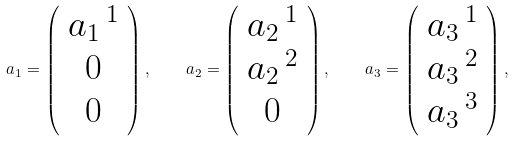Convert formula to latex. <formula><loc_0><loc_0><loc_500><loc_500>a _ { 1 } = \left ( \begin{array} { c } a _ { 1 } \, ^ { 1 } \\ 0 \\ 0 \end{array} \right ) , \quad a _ { 2 } = \left ( \begin{array} { c } a _ { 2 } \, ^ { 1 } \\ a _ { 2 } \, ^ { 2 } \\ 0 \end{array} \right ) , \quad a _ { 3 } = \left ( \begin{array} { c } a _ { 3 } \, ^ { 1 } \\ a _ { 3 } \, ^ { 2 } \\ a _ { 3 } \, ^ { 3 } \end{array} \right ) ,</formula> 